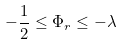<formula> <loc_0><loc_0><loc_500><loc_500>- \frac { 1 } { 2 } \leq \Phi _ { r } \leq - \lambda</formula> 